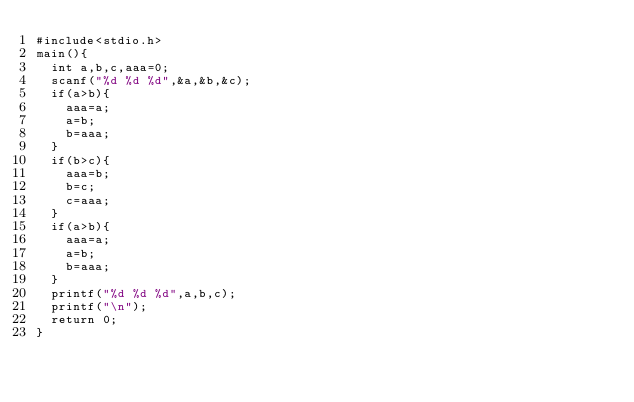<code> <loc_0><loc_0><loc_500><loc_500><_C_>#include<stdio.h>
main(){
  int a,b,c,aaa=0;
  scanf("%d %d %d",&a,&b,&c);
  if(a>b){
    aaa=a;
    a=b;
    b=aaa;
  }
  if(b>c){
    aaa=b;
    b=c;
    c=aaa;
  }
  if(a>b){
    aaa=a;
    a=b;
    b=aaa;
  }
  printf("%d %d %d",a,b,c);
  printf("\n");
  return 0;
}

    </code> 